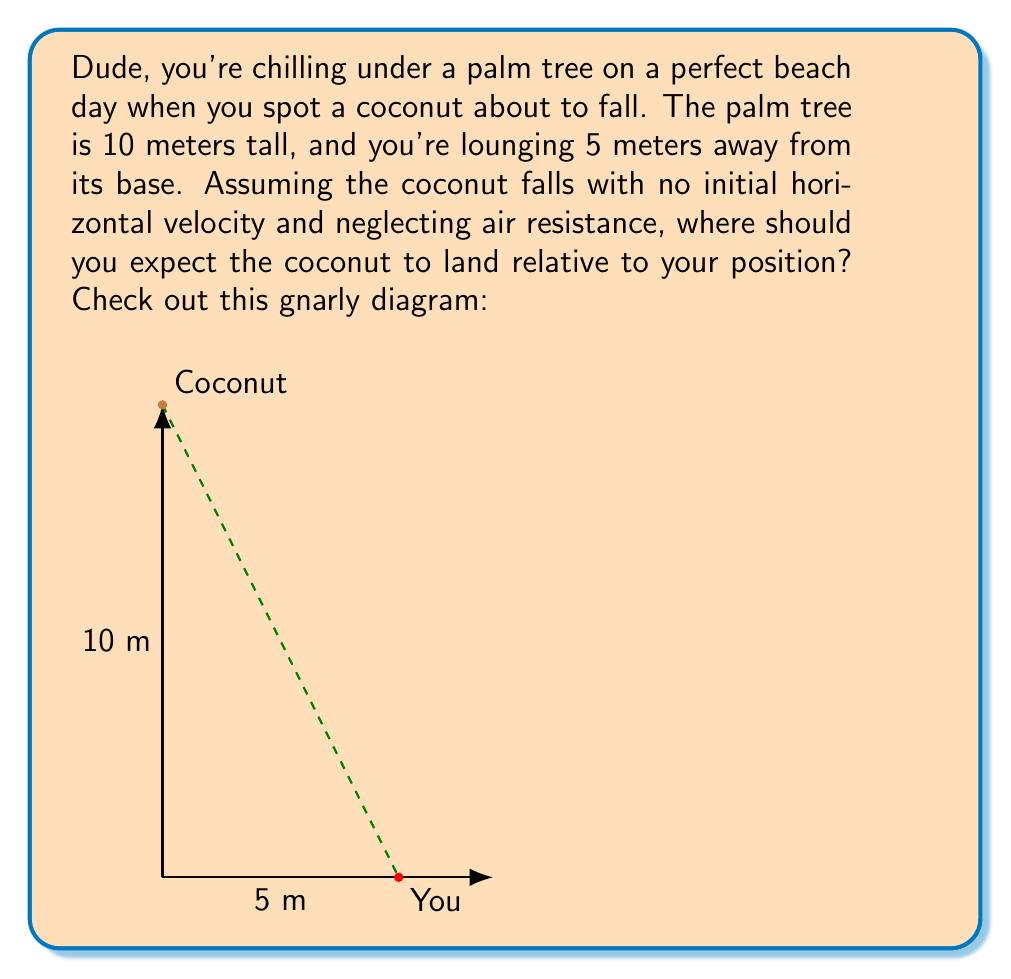Help me with this question. Alright, let's break this down step-by-step:

1) First, we need to recognize that this is a projectile motion problem. The coconut's path will form a parabola.

2) We can use the equation for the horizontal distance traveled by a projectile:

   $$x = v_0 \cos(\theta) \cdot t$$

   Where $x$ is the horizontal distance, $v_0$ is the initial velocity, $\theta$ is the launch angle, and $t$ is the time of flight.

3) In this case, $v_0 \cos(\theta) = 0$ because there's no initial horizontal velocity.

4) For the vertical motion, we use:

   $$y = h - \frac{1}{2}gt^2$$

   Where $y$ is the vertical position, $h$ is the initial height, $g$ is the acceleration due to gravity (9.8 m/s²), and $t$ is time.

5) We want to find $t$ when $y = 0$ (when the coconut hits the ground):

   $$0 = 10 - \frac{1}{2}(9.8)t^2$$

6) Solving for $t$:

   $$t = \sqrt{\frac{2(10)}{9.8}} \approx 1.43 \text{ seconds}$$

7) Since there's no horizontal velocity, the coconut will fall straight down.

Therefore, the coconut will land directly beneath where it started, which is at the base of the palm tree, 5 meters away from your position.
Answer: 5 meters away 